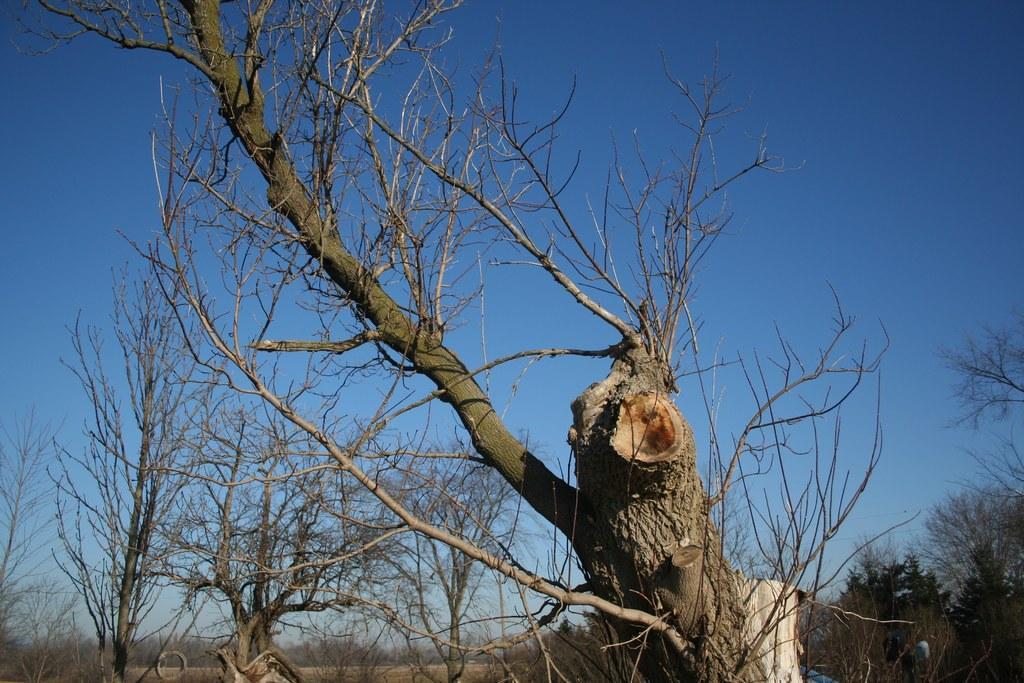Can you describe this image briefly? In this image I can see few dried trees. Background I can see sky in blue color. 